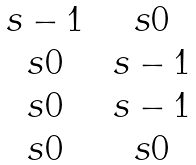Convert formula to latex. <formula><loc_0><loc_0><loc_500><loc_500>\begin{matrix} \ s - 1 & \ s 0 \\ \ s 0 & \ s - 1 \\ \ s 0 & \ s - 1 \\ \ s 0 & \ s 0 \end{matrix}</formula> 